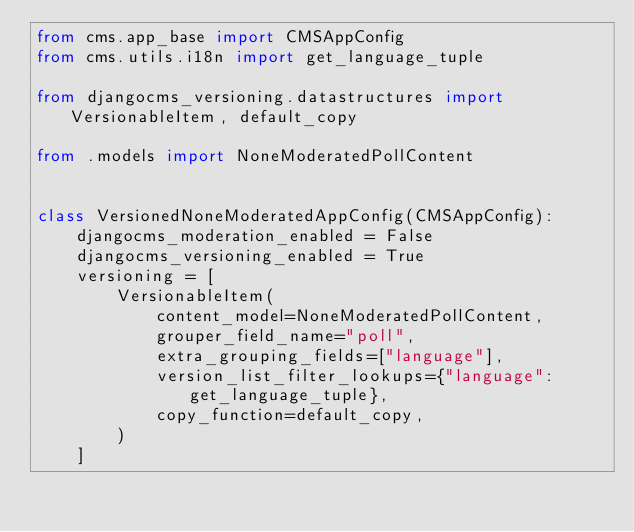Convert code to text. <code><loc_0><loc_0><loc_500><loc_500><_Python_>from cms.app_base import CMSAppConfig
from cms.utils.i18n import get_language_tuple

from djangocms_versioning.datastructures import VersionableItem, default_copy

from .models import NoneModeratedPollContent


class VersionedNoneModeratedAppConfig(CMSAppConfig):
    djangocms_moderation_enabled = False
    djangocms_versioning_enabled = True
    versioning = [
        VersionableItem(
            content_model=NoneModeratedPollContent,
            grouper_field_name="poll",
            extra_grouping_fields=["language"],
            version_list_filter_lookups={"language": get_language_tuple},
            copy_function=default_copy,
        )
    ]
</code> 